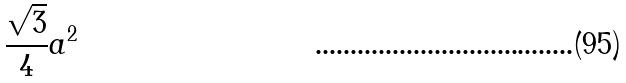<formula> <loc_0><loc_0><loc_500><loc_500>\frac { \sqrt { 3 } } { 4 } a ^ { 2 }</formula> 